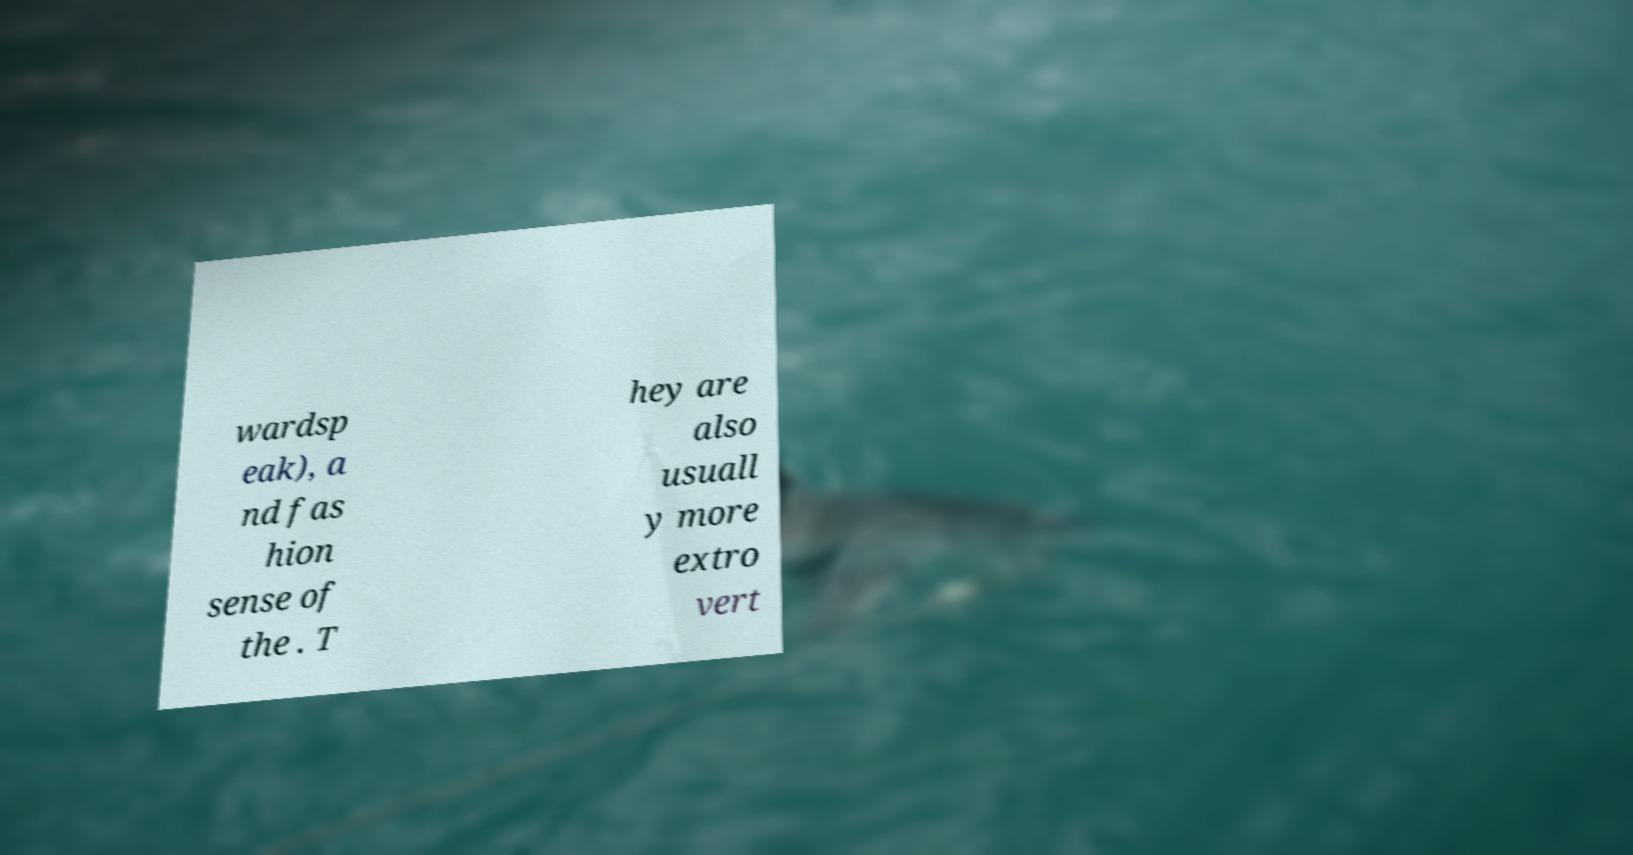What messages or text are displayed in this image? I need them in a readable, typed format. wardsp eak), a nd fas hion sense of the . T hey are also usuall y more extro vert 